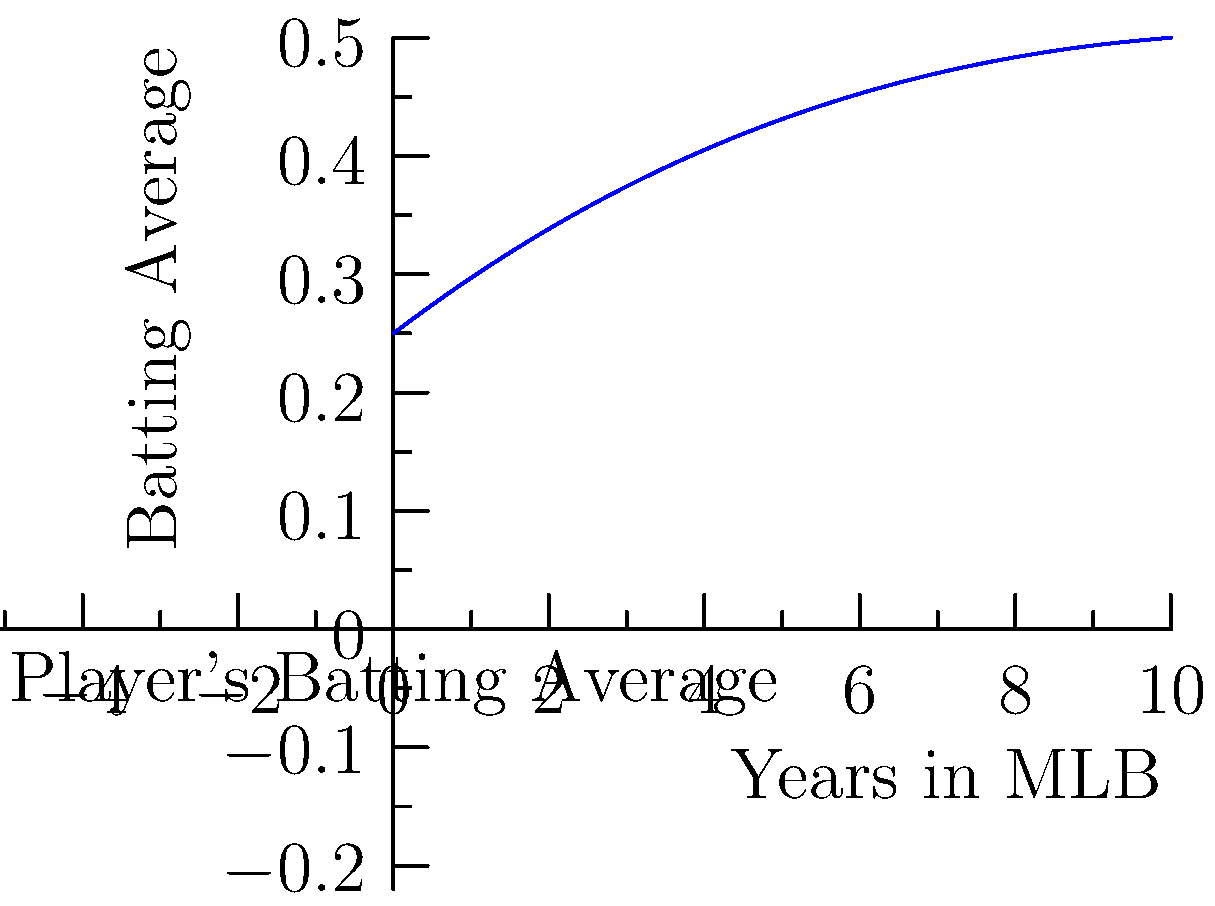Examine the polynomial trend line representing a baseball player's batting average over their first 10 years in Major League Baseball (MLB). Based on this graph, in which year of the player's career did they likely achieve their peak batting average? To determine the year of the player's peak batting average, we need to analyze the polynomial trend line:

1. The x-axis represents the player's years in MLB (0-10).
2. The y-axis represents the batting average.
3. The curve is a cubic polynomial, which has one inflection point.
4. The peak of the curve represents the highest batting average.

To find the peak:
1. Observe that the curve rises from year 0, reaches a maximum, then declines.
2. Visually estimate the x-coordinate (year) where the curve reaches its highest point.
3. This appears to be between year 3 and 4, closer to year 3.

Given the limited precision of visual estimation and the question asking for a specific year, we can conclude that the peak is likely achieved in year 3 of the player's MLB career.
Answer: Year 3 